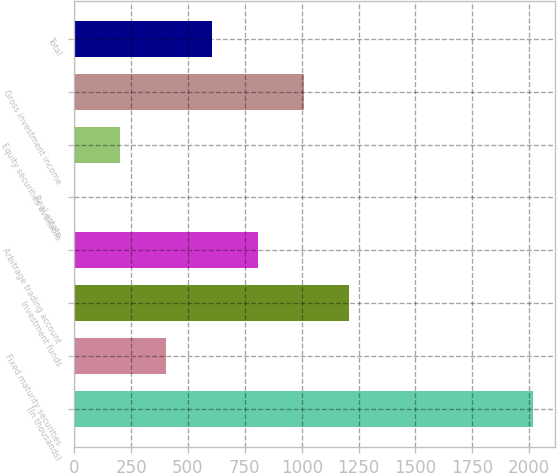Convert chart to OTSL. <chart><loc_0><loc_0><loc_500><loc_500><bar_chart><fcel>(In thousands)<fcel>Fixed maturity securities<fcel>Investment funds<fcel>Arbitrage trading account<fcel>Real estate<fcel>Equity securities available<fcel>Gross investment income<fcel>Total<nl><fcel>2015<fcel>404.12<fcel>1209.56<fcel>806.84<fcel>1.4<fcel>202.76<fcel>1008.2<fcel>605.48<nl></chart> 